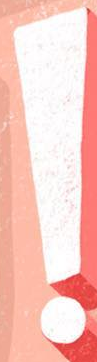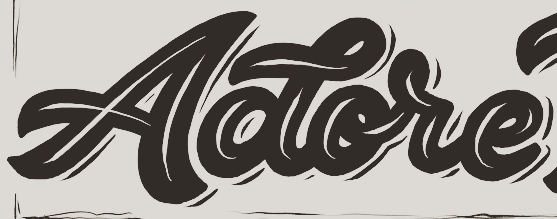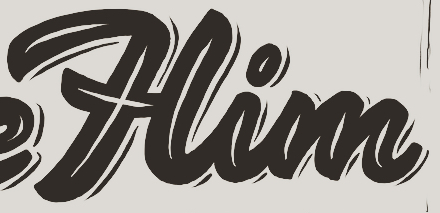What text appears in these images from left to right, separated by a semicolon? !; Aotore; Him 